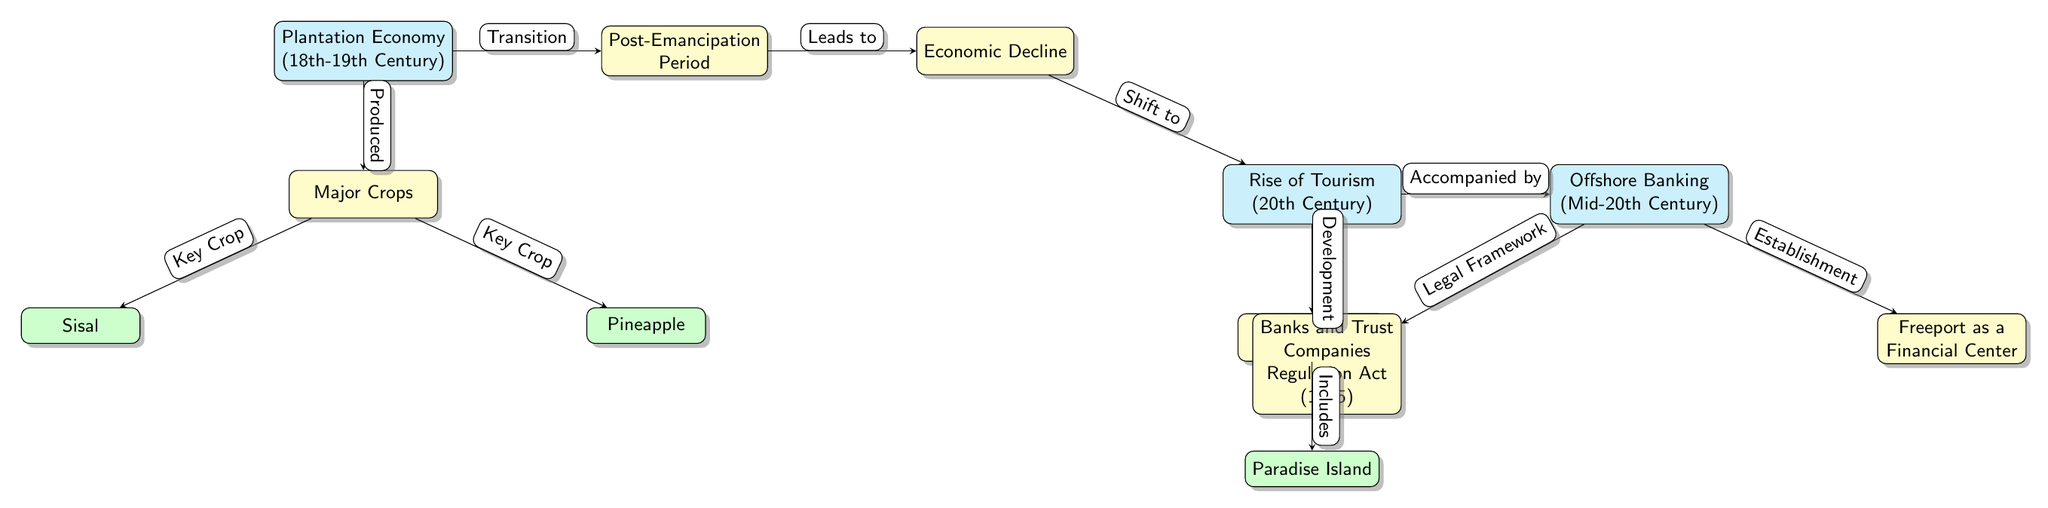What economic system is depicted in the first node? The first node in the diagram states "Plantation Economy (18th-19th Century)", which directly identifies the economic system being illustrated.
Answer: Plantation Economy (18th-19th Century) Which crops are listed in the diagram? The diagram includes two key crops connected to the "Major Crops" node: "Sisal" and "Pineapple". These crops are explicitly mentioned below the Major Crops node.
Answer: Sisal, Pineapple What period follows the Plantation Economy? The diagram shows the "Post-Emancipation Period" node directly to the right of the "Plantation Economy" node, indicating it as the following period.
Answer: Post-Emancipation Period How did the "Economic Decline" relate to tourism? The diagram indicates that "Economic Decline" leads to the "Rise of Tourism (20th Century)" node, showing a direct link between these two stages.
Answer: Leads to What major development occurred in the 20th century according to the diagram? The diagram indicates that the "Rise of Tourism (20th Century)" was a major development, clearly marked as a significant evolution in the economy.
Answer: Rise of Tourism (20th Century) What legal framework was established related to offshore banking? The "Banks and Trust Companies Regulation Act (1965)" node is shown connected to "Offshore Banking", indicating it as the legal framework associated with this sector.
Answer: Banks and Trust Companies Regulation Act (1965) What connection exists between the rise of tourism and offshore banking? According to the diagram, the "Rise of Tourism (20th Century)" is "Accompanied by" the "Offshore Banking (Mid-20th Century)", illustrating that both developments occurred in tandem.
Answer: Accompanied by Which node is considered the first resort mentioned? The "First Resorts" node directly under the "Rise of Tourism" node identifies the initial establishment within the tourism sector in the diagram.
Answer: First Resorts How many nodes are there in total in the diagram? By counting the nodes displayed in the diagram, there are a total of 11 nodes, encapsulating various stages and elements of the economic evolution of the Bahamas.
Answer: 11 